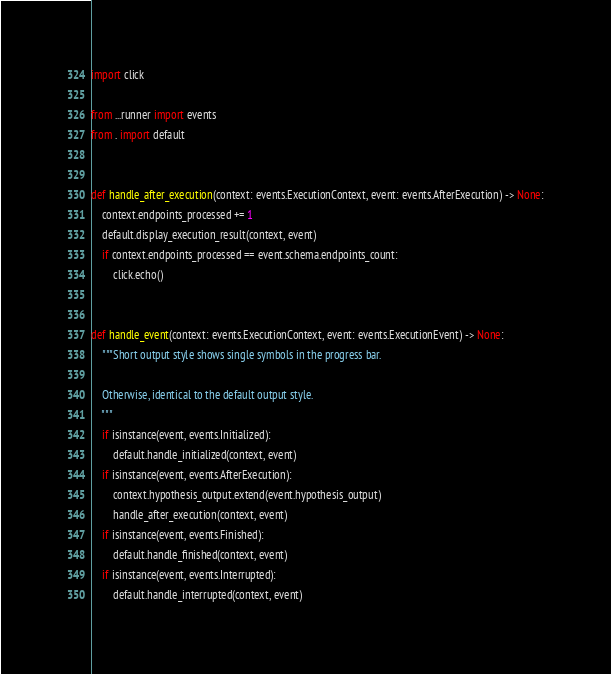<code> <loc_0><loc_0><loc_500><loc_500><_Python_>import click

from ...runner import events
from . import default


def handle_after_execution(context: events.ExecutionContext, event: events.AfterExecution) -> None:
    context.endpoints_processed += 1
    default.display_execution_result(context, event)
    if context.endpoints_processed == event.schema.endpoints_count:
        click.echo()


def handle_event(context: events.ExecutionContext, event: events.ExecutionEvent) -> None:
    """Short output style shows single symbols in the progress bar.

    Otherwise, identical to the default output style.
    """
    if isinstance(event, events.Initialized):
        default.handle_initialized(context, event)
    if isinstance(event, events.AfterExecution):
        context.hypothesis_output.extend(event.hypothesis_output)
        handle_after_execution(context, event)
    if isinstance(event, events.Finished):
        default.handle_finished(context, event)
    if isinstance(event, events.Interrupted):
        default.handle_interrupted(context, event)
</code> 